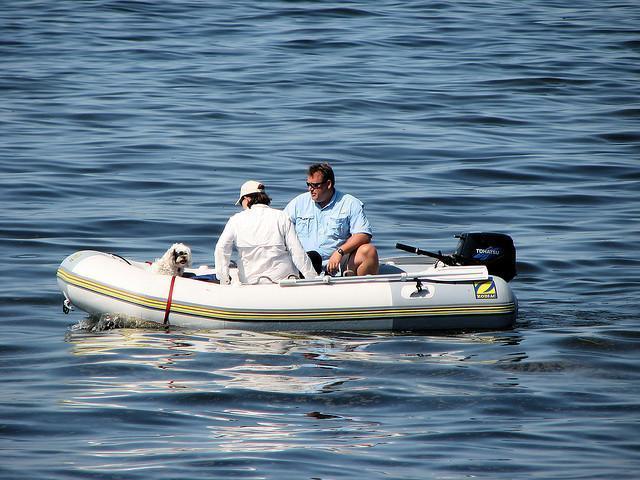How many people are in the boat?
Give a very brief answer. 2. How many people are there?
Give a very brief answer. 2. How many cups on the table are wine glasses?
Give a very brief answer. 0. 